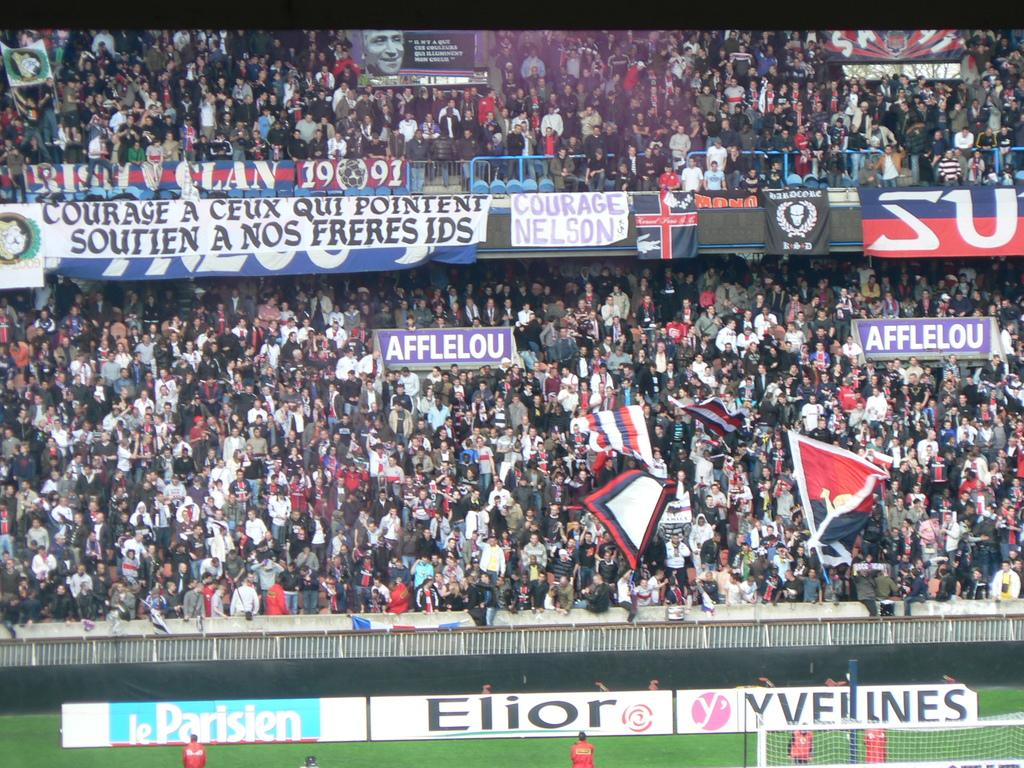<image>
Give a short and clear explanation of the subsequent image. A large sports arena with people and an advertisement for Elior on a sign near the field. 